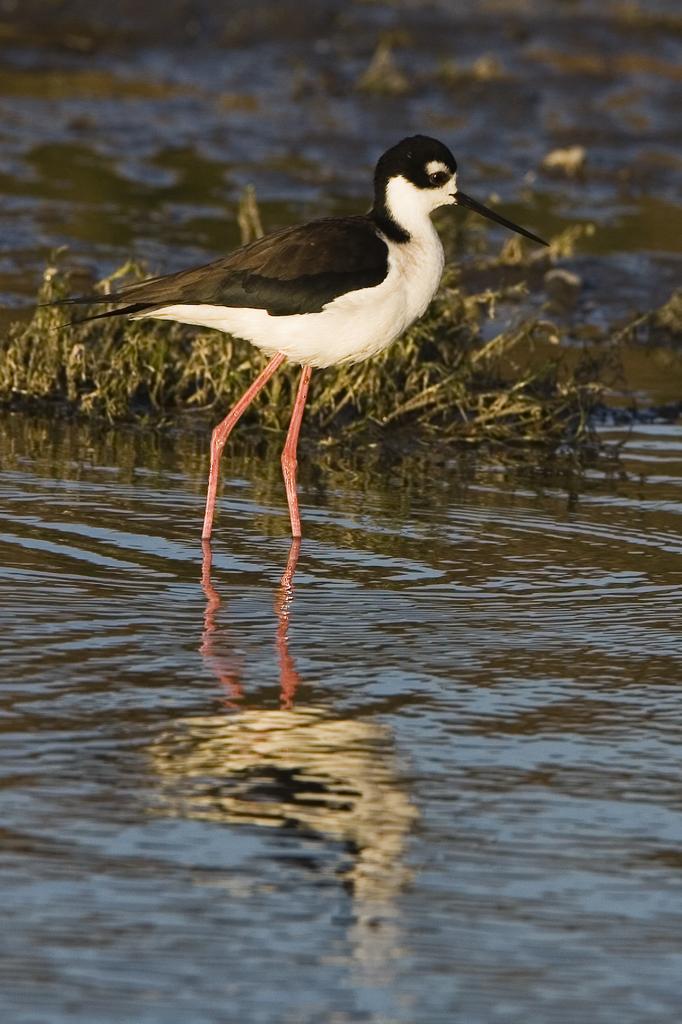In one or two sentences, can you explain what this image depicts? In this image we can see a bird in the water and there are some plants. 